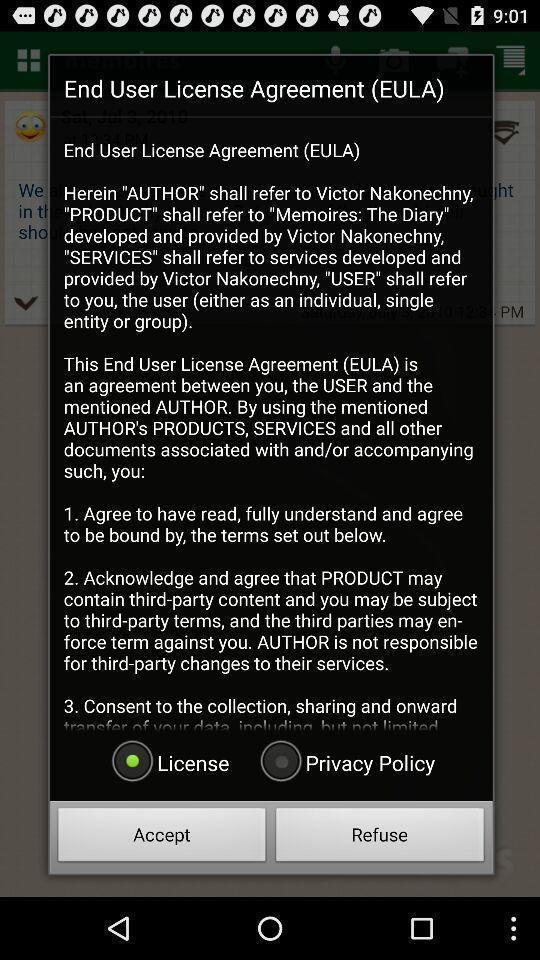What details can you identify in this image? Pop-up showing to accept license agreement. 